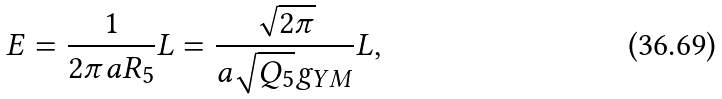Convert formula to latex. <formula><loc_0><loc_0><loc_500><loc_500>E = \frac { 1 } { 2 \pi a R _ { 5 } } L = \frac { \sqrt { 2 \pi } } { a \sqrt { Q _ { 5 } } g _ { Y M } } L ,</formula> 